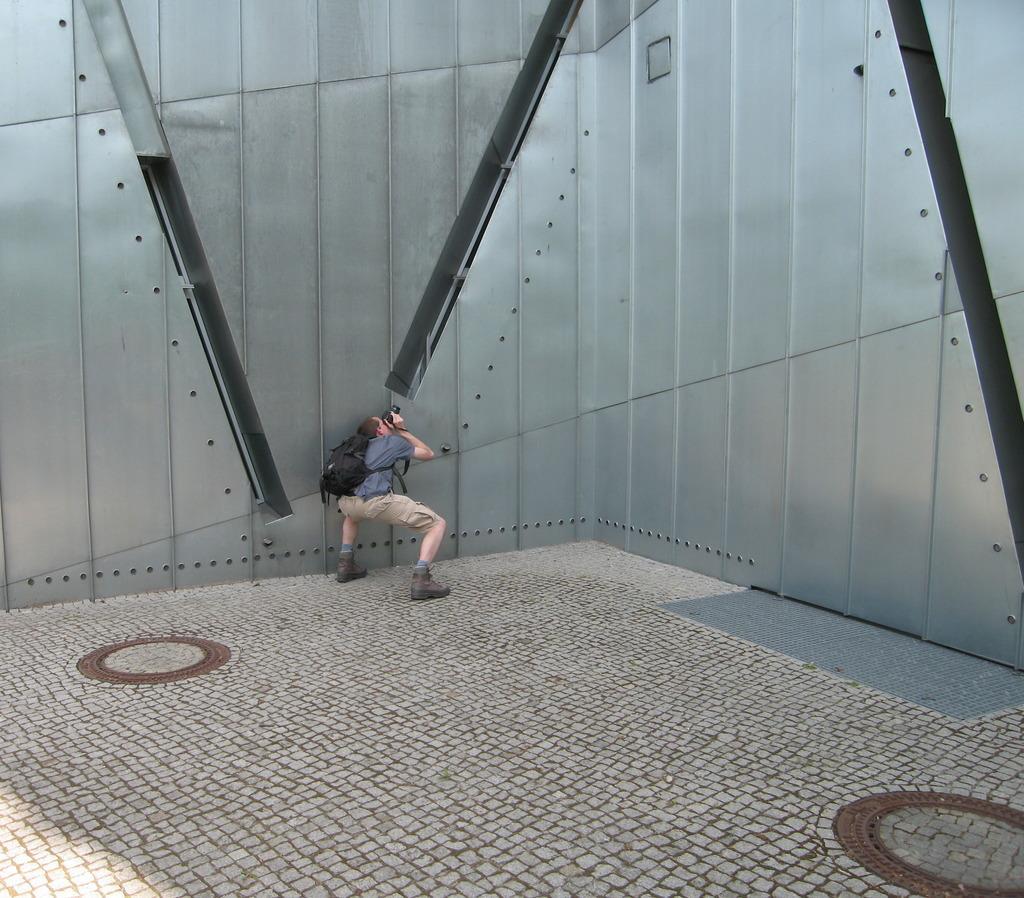Can you describe this image briefly? In this image, we can see a person carrying a bag and holding an object. We can see the ground and the metal wall. 